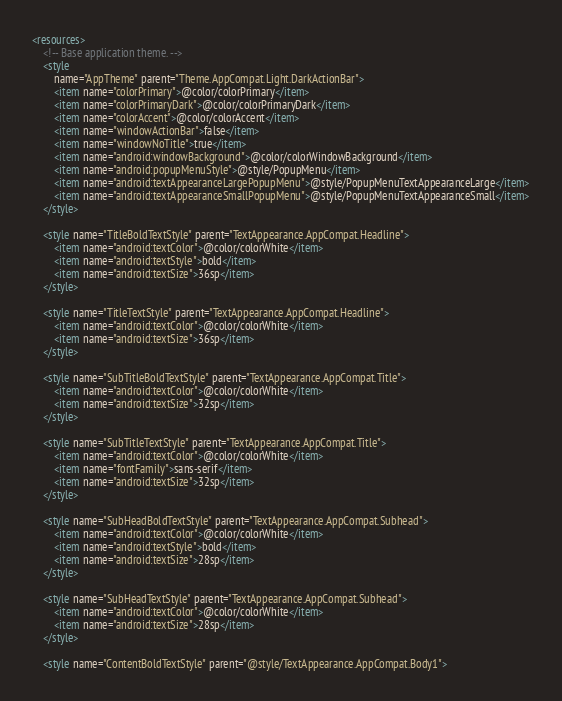<code> <loc_0><loc_0><loc_500><loc_500><_XML_><resources>
    <!-- Base application theme. -->
    <style
        name="AppTheme" parent="Theme.AppCompat.Light.DarkActionBar">
        <item name="colorPrimary">@color/colorPrimary</item>
        <item name="colorPrimaryDark">@color/colorPrimaryDark</item>
        <item name="colorAccent">@color/colorAccent</item>
        <item name="windowActionBar">false</item>
        <item name="windowNoTitle">true</item>
        <item name="android:windowBackground">@color/colorWindowBackground</item>
        <item name="android:popupMenuStyle">@style/PopupMenu</item>
        <item name="android:textAppearanceLargePopupMenu">@style/PopupMenuTextAppearanceLarge</item>
        <item name="android:textAppearanceSmallPopupMenu">@style/PopupMenuTextAppearanceSmall</item>
    </style>

    <style name="TitleBoldTextStyle" parent="TextAppearance.AppCompat.Headline">
        <item name="android:textColor">@color/colorWhite</item>
        <item name="android:textStyle">bold</item>
        <item name="android:textSize">36sp</item>
    </style>

    <style name="TitleTextStyle" parent="TextAppearance.AppCompat.Headline">
        <item name="android:textColor">@color/colorWhite</item>
        <item name="android:textSize">36sp</item>
    </style>

    <style name="SubTitleBoldTextStyle" parent="TextAppearance.AppCompat.Title">
        <item name="android:textColor">@color/colorWhite</item>
        <item name="android:textSize">32sp</item>
    </style>

    <style name="SubTitleTextStyle" parent="TextAppearance.AppCompat.Title">
        <item name="android:textColor">@color/colorWhite</item>
        <item name="fontFamily">sans-serif</item>
        <item name="android:textSize">32sp</item>
    </style>

    <style name="SubHeadBoldTextStyle" parent="TextAppearance.AppCompat.Subhead">
        <item name="android:textColor">@color/colorWhite</item>
        <item name="android:textStyle">bold</item>
        <item name="android:textSize">28sp</item>
    </style>

    <style name="SubHeadTextStyle" parent="TextAppearance.AppCompat.Subhead">
        <item name="android:textColor">@color/colorWhite</item>
        <item name="android:textSize">28sp</item>
    </style>

    <style name="ContentBoldTextStyle" parent="@style/TextAppearance.AppCompat.Body1"></code> 